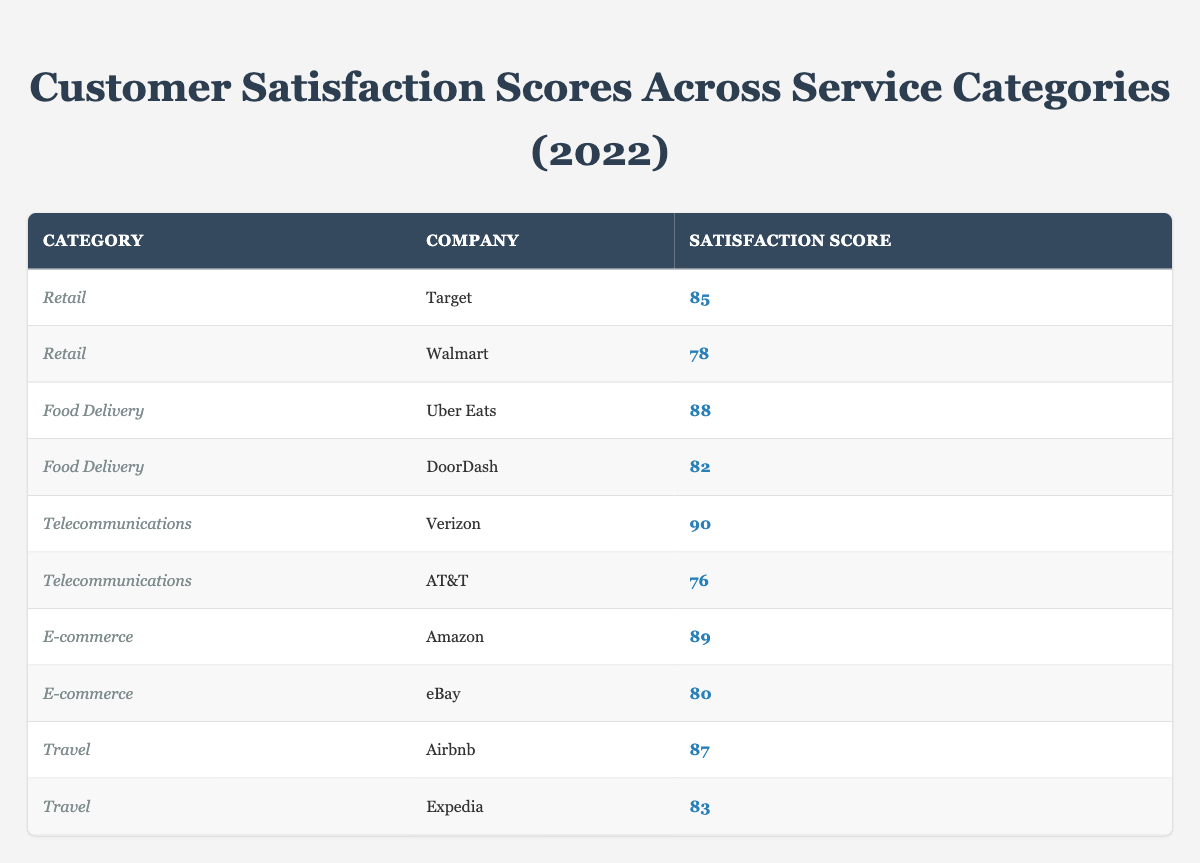What is the satisfaction score for Target in the retail category? The table shows that Target is listed under the retail category with a satisfaction score of 85. Therefore, the answer is directly retrieved from the relevant row of the table.
Answer: 85 Which company has the highest satisfaction score in the telecommunications category? Looking at the telecommunications category in the table, Verizon has a satisfaction score of 90, while AT&T has a score of 76. Comparing these scores indicates that Verizon has the highest satisfaction score.
Answer: Verizon What is the average satisfaction score for all food delivery companies listed? The table lists two food delivery companies: Uber Eats with a score of 88 and DoorDash with a score of 82. To find the average, we sum these scores: 88 + 82 = 170, and then divide by 2 (the number of companies): 170 / 2 = 85.
Answer: 85 Is it true that Amazon has a higher satisfaction score than eBay? According to the table, Amazon has a satisfaction score of 89, while eBay has a score of 80. Since 89 > 80 is true, the answer to this fact-based question is yes.
Answer: Yes What is the difference in satisfaction scores between the highest and lowest-rated retail company? In the retail category, Target has a score of 85 and Walmart has a score of 78. To find the difference, we subtract Walmart's score from Target's: 85 - 78 = 7. Therefore, the difference in satisfaction scores is 7.
Answer: 7 Which service category has the highest average satisfaction score? To determine this, we calculate the average scores for each category: Retail average is (85 + 78) / 2 = 81.5; Food Delivery average is (88 + 82) / 2 = 85; Telecommunications average is (90 + 76) / 2 = 83; E-commerce average is (89 + 80) / 2 = 84.5; Travel average is (87 + 83) / 2 = 85. The highest average is 85 for both Food Delivery and Travel.
Answer: Food Delivery and Travel What are the satisfaction scores for both companies in the travel category? The table lists two travel companies: Airbnb with a satisfaction score of 87 and Expedia with a score of 83. These scores can be directly retrieved from the relevant rows in the table.
Answer: Airbnb: 87, Expedia: 83 Is DoorDash rated higher than Target? According to the table, DoorDash has a satisfaction score of 82 while Target has a score of 85. Since 82 < 85, it is false that DoorDash is rated higher than Target.
Answer: No 